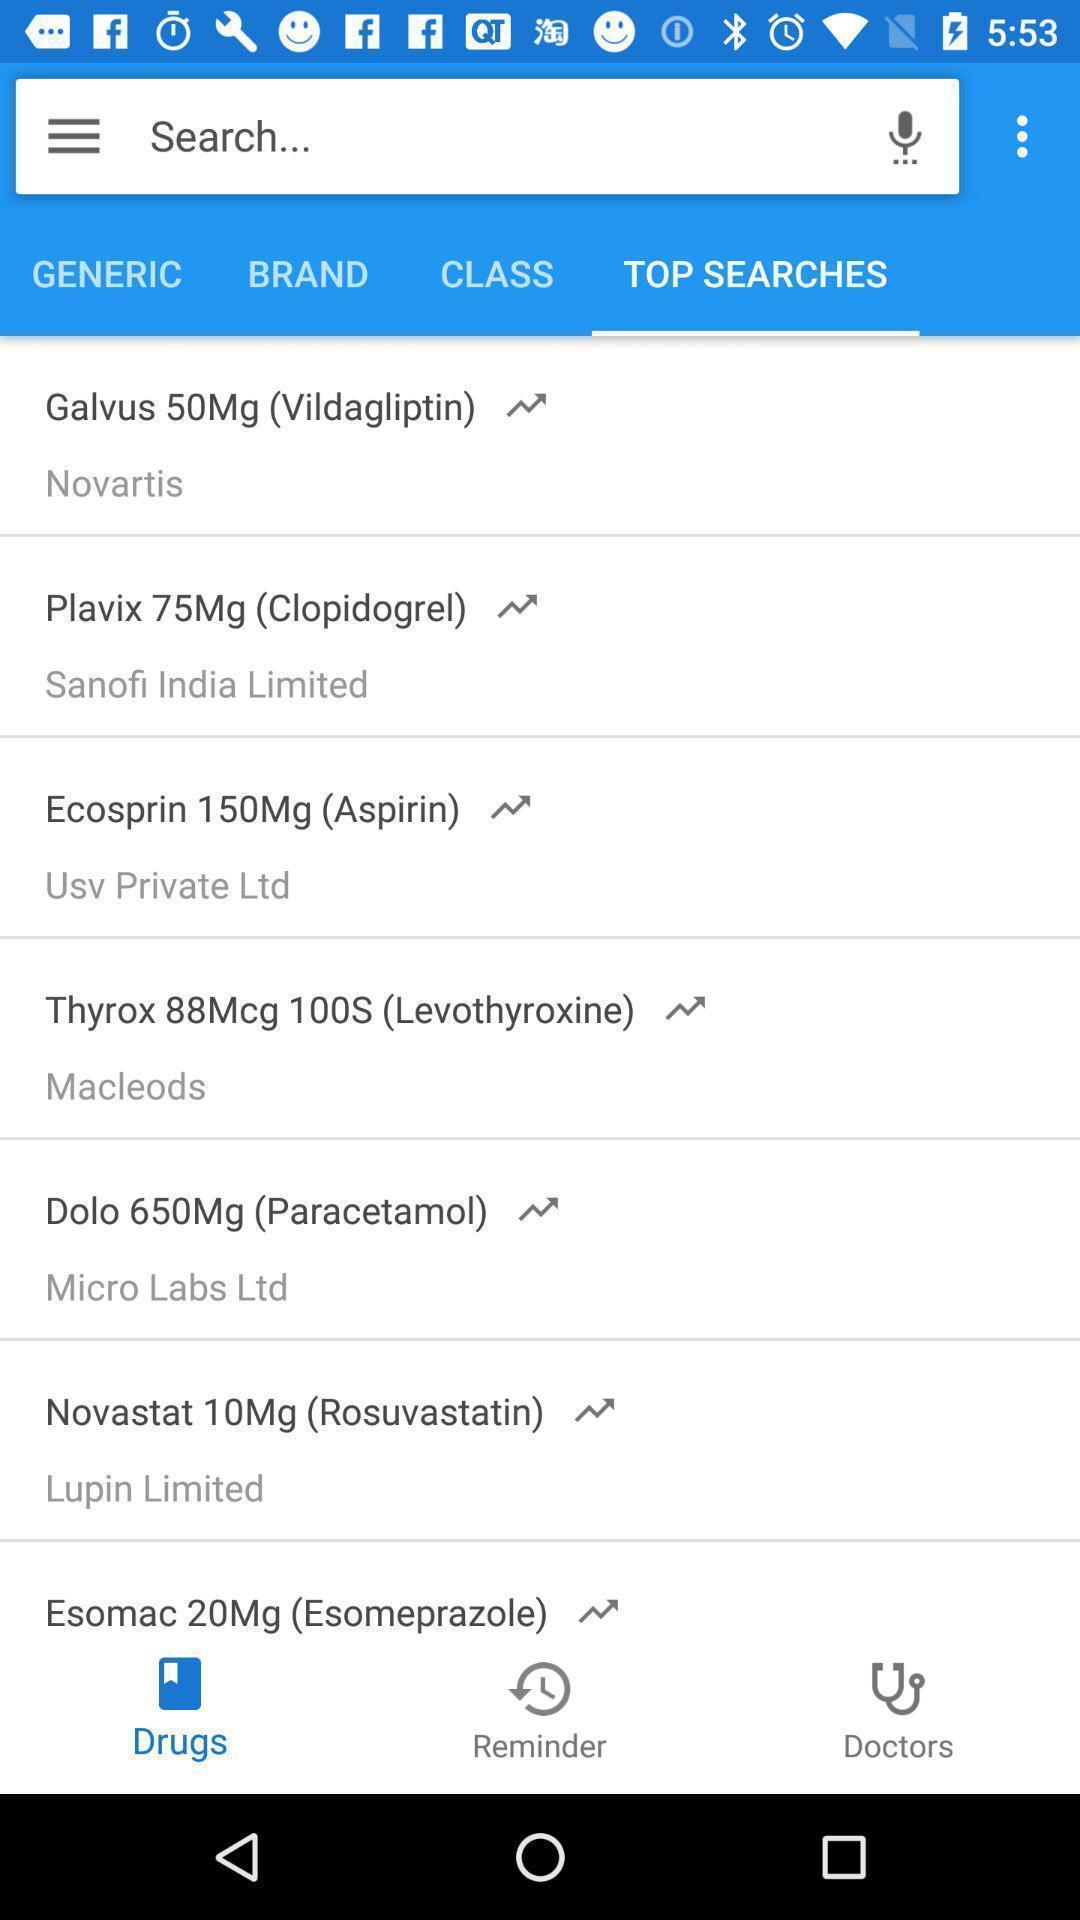Summarize the main components in this picture. Search bar to find medicines in the medical app. 